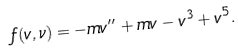<formula> <loc_0><loc_0><loc_500><loc_500>f ( v , \nu ) = - m v ^ { \prime \prime } + m v - v ^ { 3 } + v ^ { 5 } .</formula> 